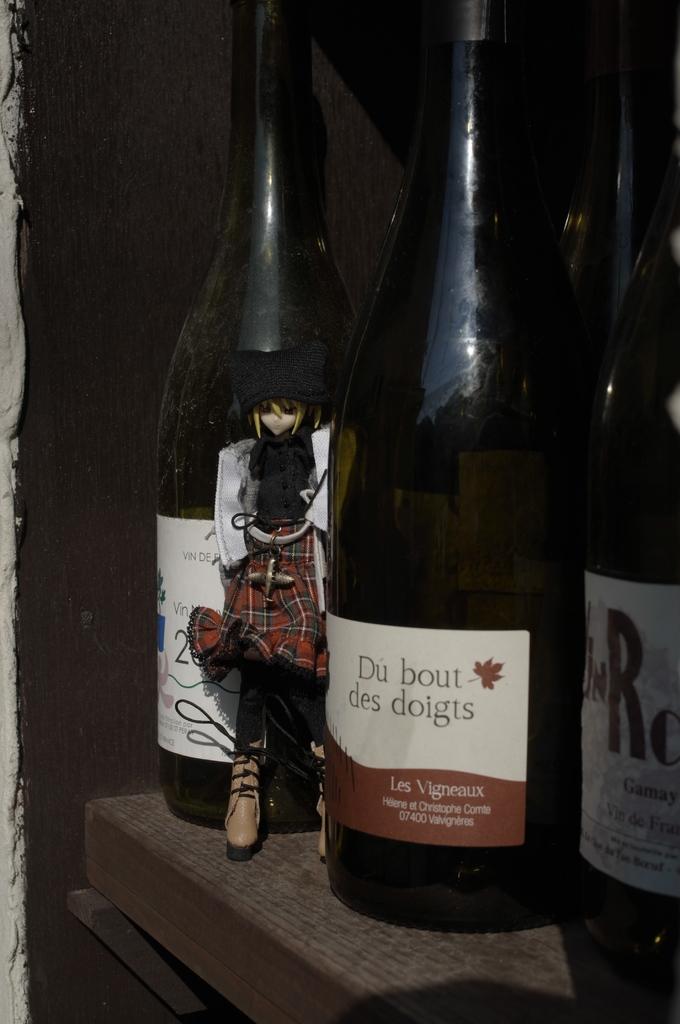What word is to the left of the brown leaf on the label?
Provide a short and direct response. Bout. 